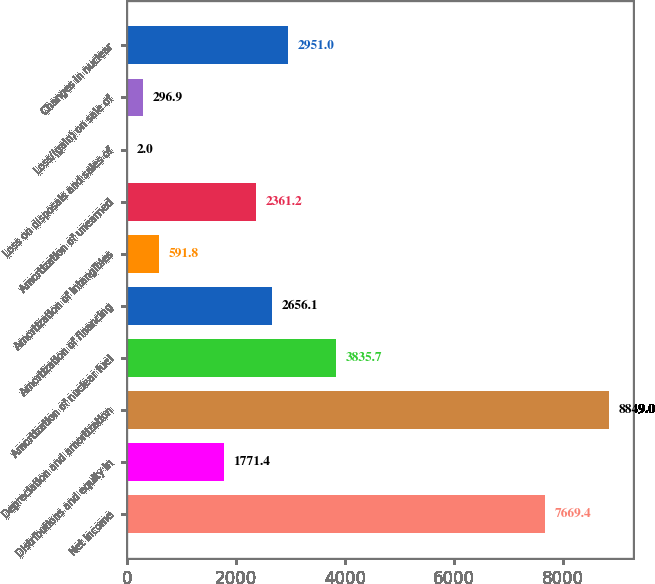Convert chart. <chart><loc_0><loc_0><loc_500><loc_500><bar_chart><fcel>Net income<fcel>Distributions and equity in<fcel>Depreciation and amortization<fcel>Amortization of nuclear fuel<fcel>Amortization of financing<fcel>Amortization of intangibles<fcel>Amortization of unearned<fcel>Loss on disposals and sales of<fcel>Loss/(gain) on sale of<fcel>Changes in nuclear<nl><fcel>7669.4<fcel>1771.4<fcel>8849<fcel>3835.7<fcel>2656.1<fcel>591.8<fcel>2361.2<fcel>2<fcel>296.9<fcel>2951<nl></chart> 